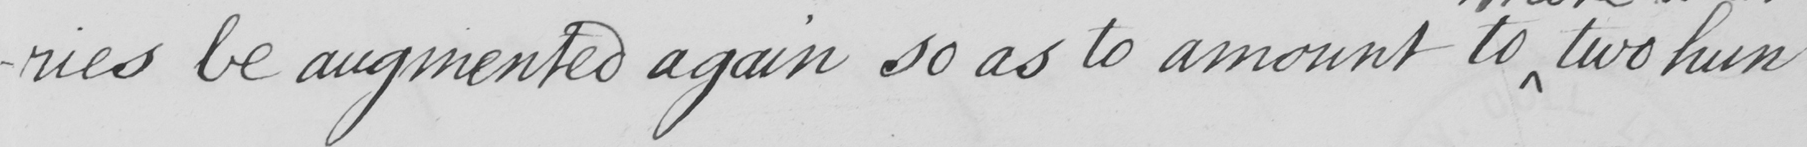Can you read and transcribe this handwriting? -ries be augmented again so as to amount to two hun- 